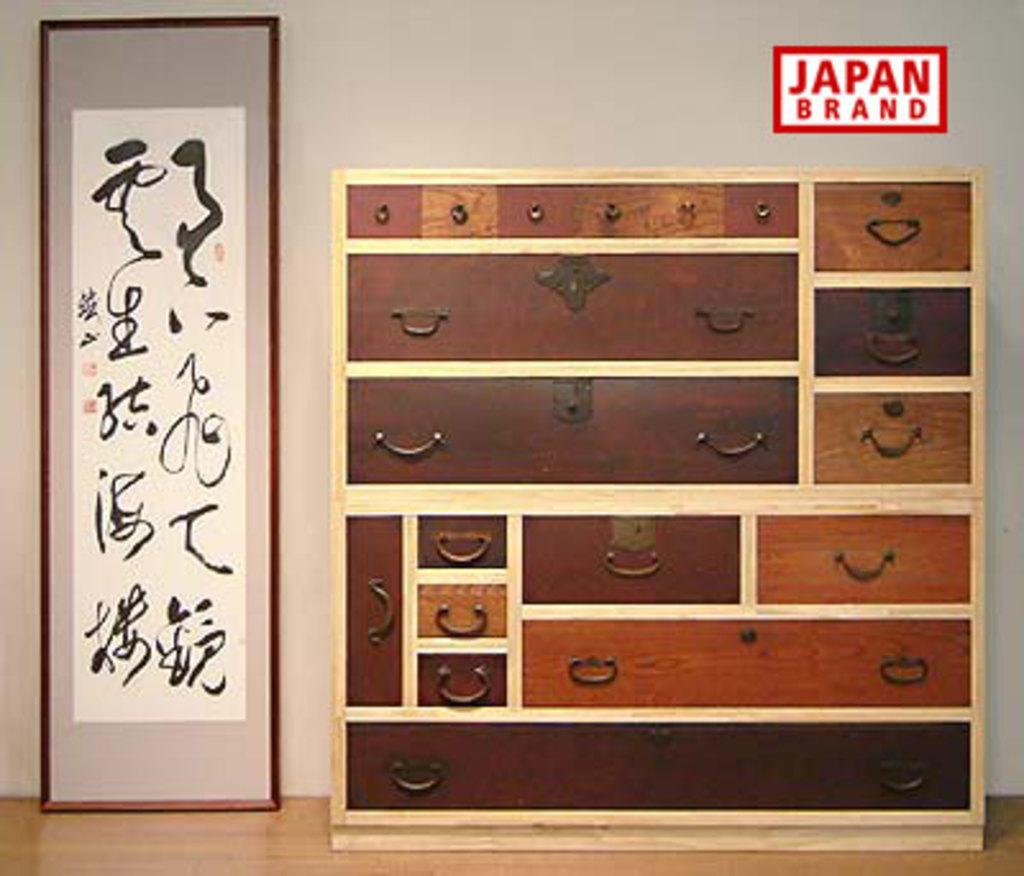What type of furniture is present in the image? There are cabinets in the image. Where is the photo frame located in the image? There is a narrow photo frame on the left side of the image. What color is the wall in the background of the image? There is a white wall at the back of the image. What type of flooring is visible in the image? There is a wooden floor in the image. What type of mint can be seen growing on the wooden floor in the image? There is no mint visible in the image; the wooden floor is not associated with any plants or vegetation. 